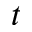<formula> <loc_0><loc_0><loc_500><loc_500>t</formula> 